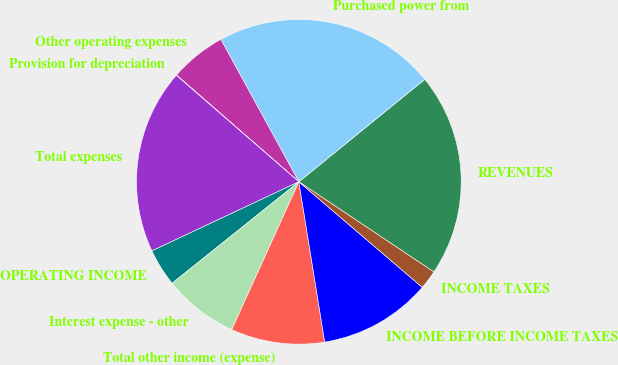<chart> <loc_0><loc_0><loc_500><loc_500><pie_chart><fcel>REVENUES<fcel>Purchased power from<fcel>Other operating expenses<fcel>Provision for depreciation<fcel>Total expenses<fcel>OPERATING INCOME<fcel>Interest expense - other<fcel>Total other income (expense)<fcel>INCOME BEFORE INCOME TAXES<fcel>INCOME TAXES<nl><fcel>20.24%<fcel>22.1%<fcel>5.61%<fcel>0.03%<fcel>18.38%<fcel>3.75%<fcel>7.47%<fcel>9.33%<fcel>11.19%<fcel>1.89%<nl></chart> 